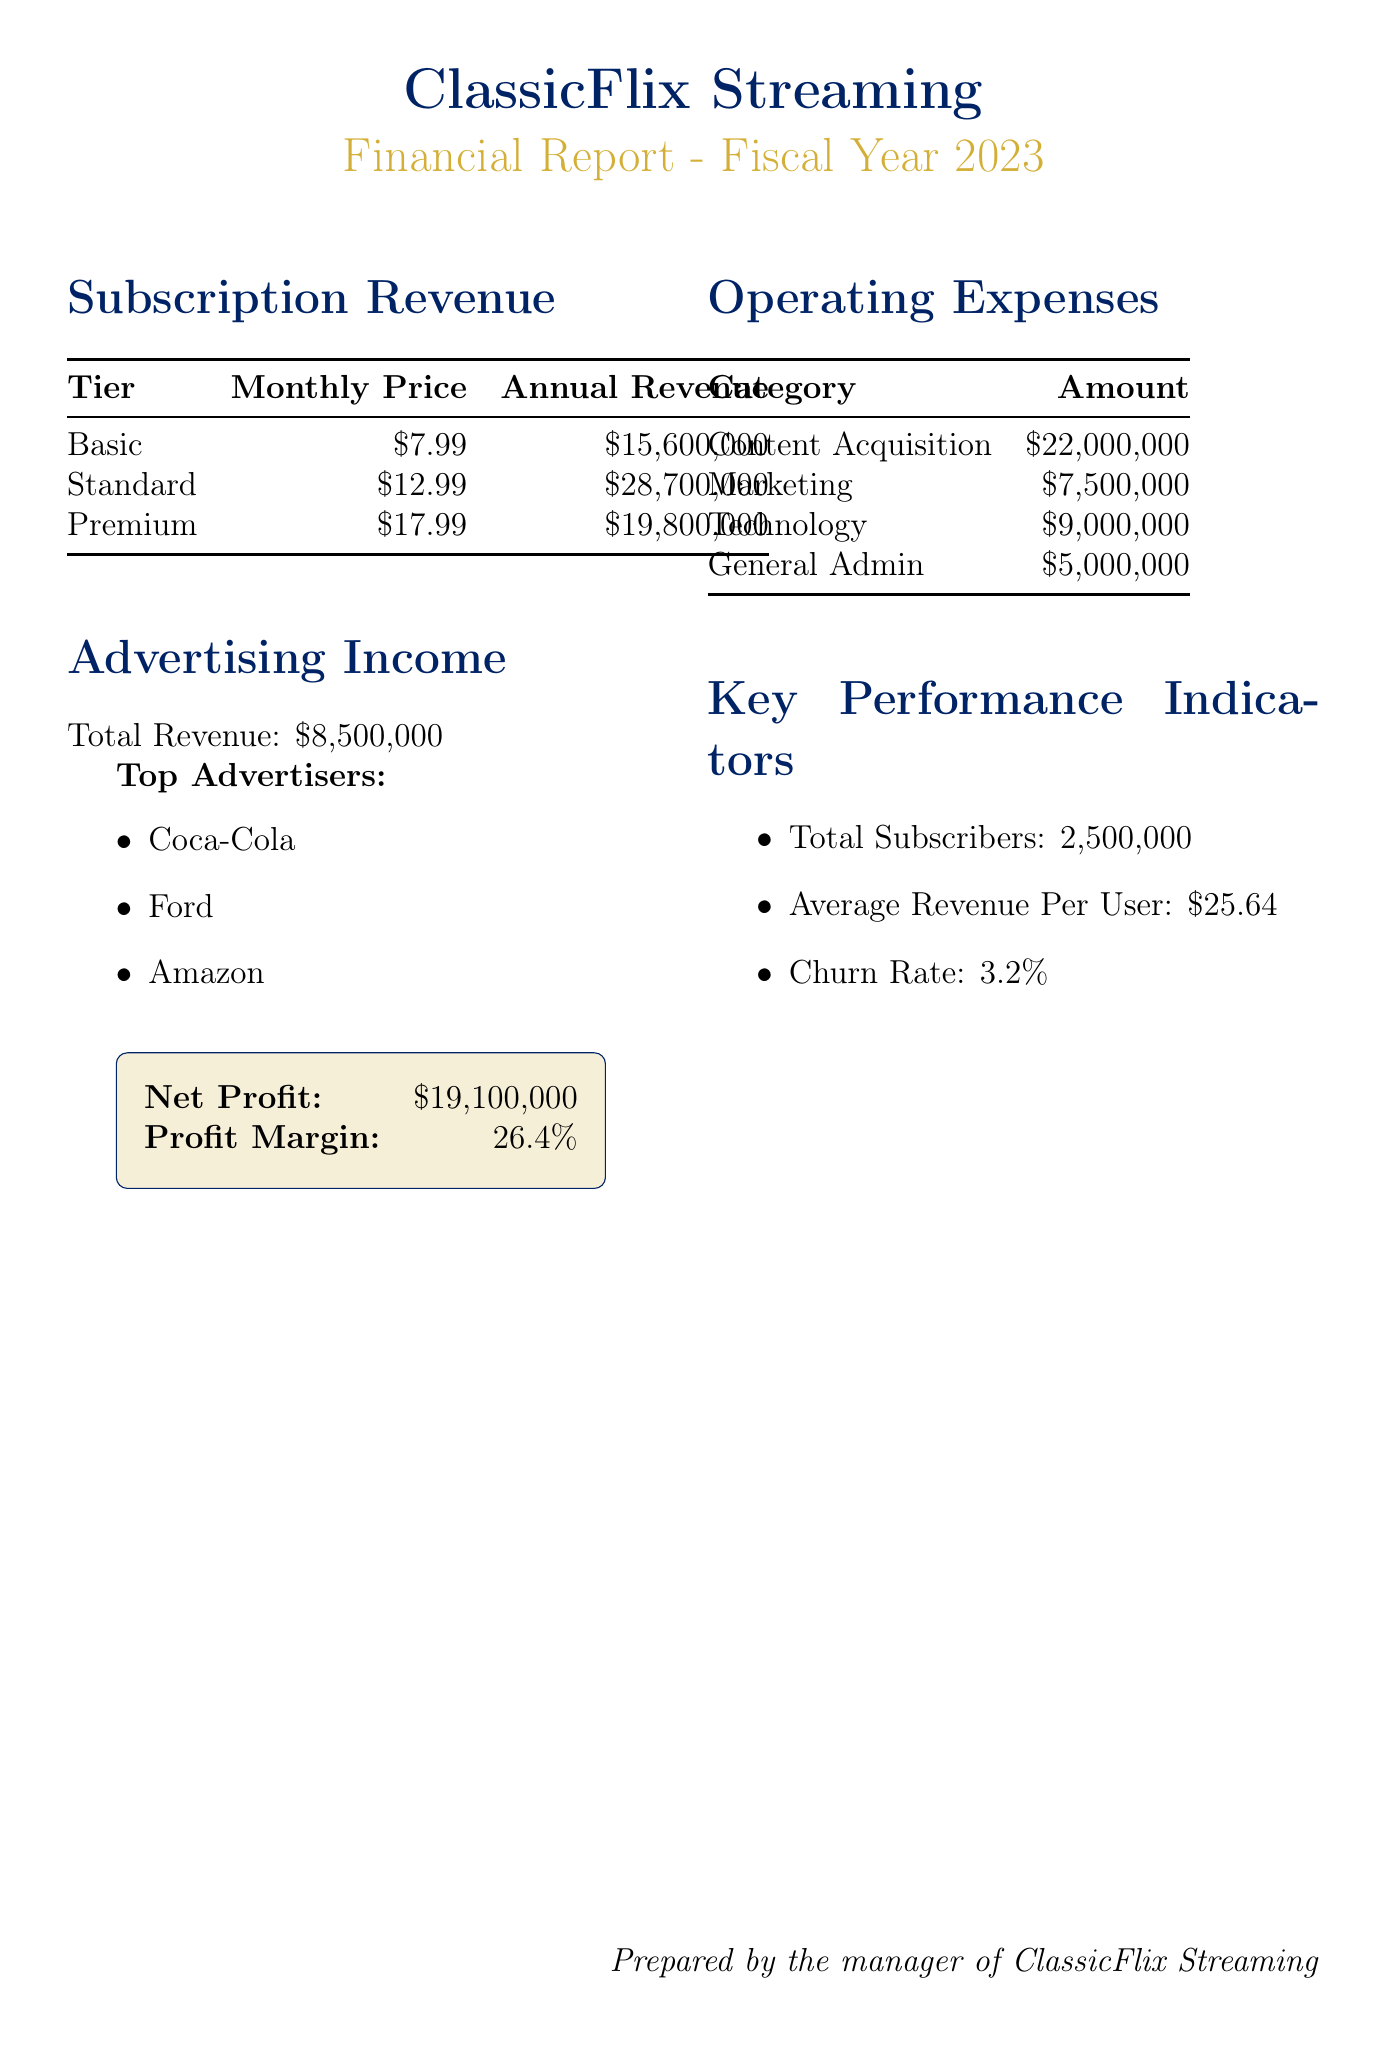What is the total revenue from the Basic subscription tier? The annual revenue from the Basic subscription tier is directly stated in the document as $15,600,000.
Answer: $15,600,000 What is the monthly price for the Premium subscription tier? The monthly price for the Premium subscription tier is clearly indicated in the document as $17.99.
Answer: $17.99 What is the total advertising income? The document states that the total advertising income for the year is $8,500,000.
Answer: $8,500,000 Which company is listed as one of the top advertisers? The document mentions a list of top advertisers, and one of them is Coca-Cola.
Answer: Coca-Cola What is the sum of the content acquisition and marketing operating expenses? To find this, we add the content acquisition of $22,000,000 and marketing of $7,500,000, which gives $29,500,000.
Answer: $29,500,000 What is the average revenue per user? The document provides the average revenue per user as $25.64.
Answer: $25.64 What percentage is the churn rate? The churn rate is presented in the document as 3.2%.
Answer: 3.2% What is the net profit reported? The net profit is directly mentioned in the document as $19,100,000.
Answer: $19,100,000 What is the profit margin percentage? The profit margin for the company is stated as 26.4% in the document.
Answer: 26.4% 